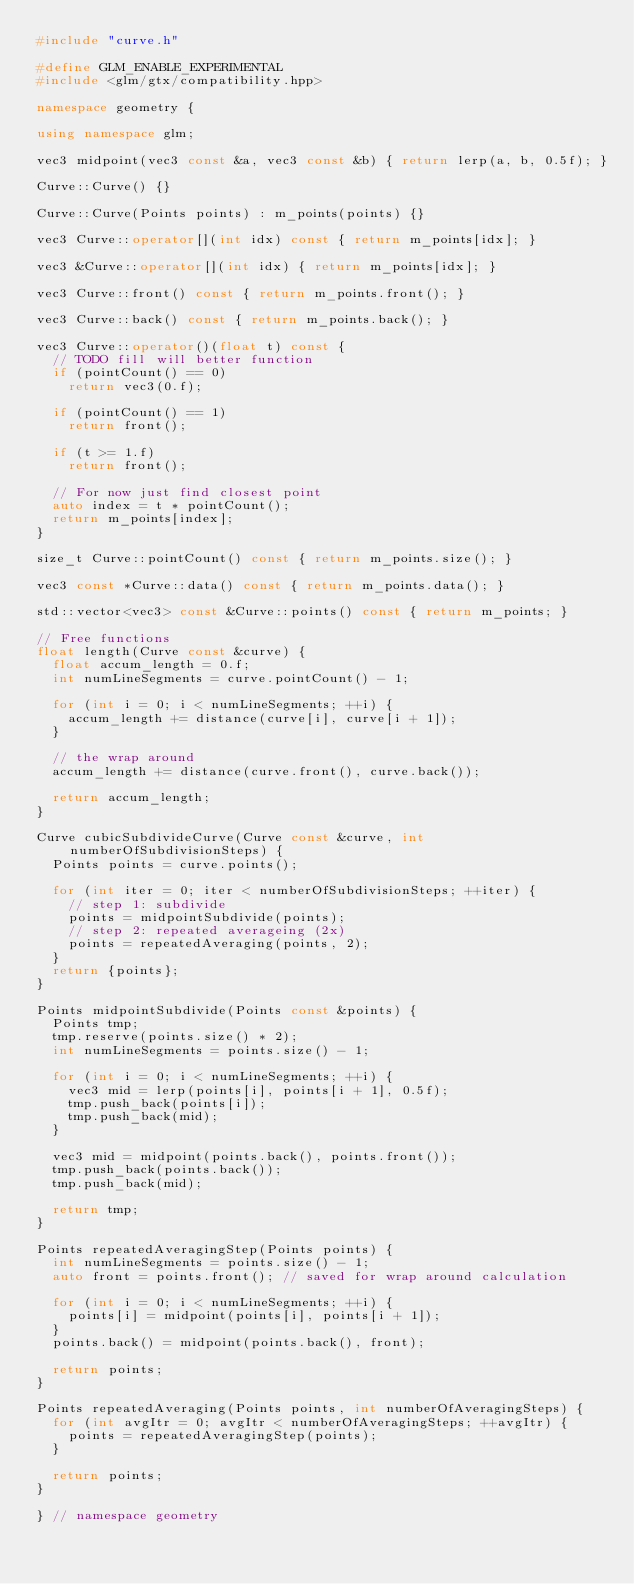<code> <loc_0><loc_0><loc_500><loc_500><_C++_>#include "curve.h"

#define GLM_ENABLE_EXPERIMENTAL
#include <glm/gtx/compatibility.hpp>

namespace geometry {

using namespace glm;

vec3 midpoint(vec3 const &a, vec3 const &b) { return lerp(a, b, 0.5f); }

Curve::Curve() {}

Curve::Curve(Points points) : m_points(points) {}

vec3 Curve::operator[](int idx) const { return m_points[idx]; }

vec3 &Curve::operator[](int idx) { return m_points[idx]; }

vec3 Curve::front() const { return m_points.front(); }

vec3 Curve::back() const { return m_points.back(); }

vec3 Curve::operator()(float t) const {
  // TODO fill will better function
  if (pointCount() == 0)
    return vec3(0.f);

  if (pointCount() == 1)
    return front();

  if (t >= 1.f)
    return front();

  // For now just find closest point
  auto index = t * pointCount();
  return m_points[index];
}

size_t Curve::pointCount() const { return m_points.size(); }

vec3 const *Curve::data() const { return m_points.data(); }

std::vector<vec3> const &Curve::points() const { return m_points; }

// Free functions
float length(Curve const &curve) {
  float accum_length = 0.f;
  int numLineSegments = curve.pointCount() - 1;

  for (int i = 0; i < numLineSegments; ++i) {
    accum_length += distance(curve[i], curve[i + 1]);
  }

  // the wrap around
  accum_length += distance(curve.front(), curve.back());

  return accum_length;
}

Curve cubicSubdivideCurve(Curve const &curve, int numberOfSubdivisionSteps) {
  Points points = curve.points();

  for (int iter = 0; iter < numberOfSubdivisionSteps; ++iter) {
    // step 1: subdivide
    points = midpointSubdivide(points);
    // step 2: repeated averageing (2x)
    points = repeatedAveraging(points, 2);
  }
  return {points};
}

Points midpointSubdivide(Points const &points) {
  Points tmp;
  tmp.reserve(points.size() * 2);
  int numLineSegments = points.size() - 1;

  for (int i = 0; i < numLineSegments; ++i) {
    vec3 mid = lerp(points[i], points[i + 1], 0.5f);
    tmp.push_back(points[i]);
    tmp.push_back(mid);
  }

  vec3 mid = midpoint(points.back(), points.front());
  tmp.push_back(points.back());
  tmp.push_back(mid);

  return tmp;
}

Points repeatedAveragingStep(Points points) {
  int numLineSegments = points.size() - 1;
  auto front = points.front(); // saved for wrap around calculation

  for (int i = 0; i < numLineSegments; ++i) {
    points[i] = midpoint(points[i], points[i + 1]);
  }
  points.back() = midpoint(points.back(), front);

  return points;
}

Points repeatedAveraging(Points points, int numberOfAveragingSteps) {
  for (int avgItr = 0; avgItr < numberOfAveragingSteps; ++avgItr) {
    points = repeatedAveragingStep(points);
  }

  return points;
}

} // namespace geometry
</code> 